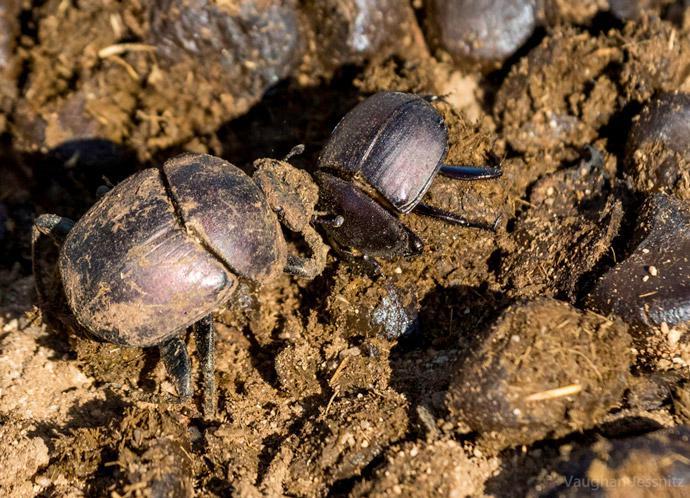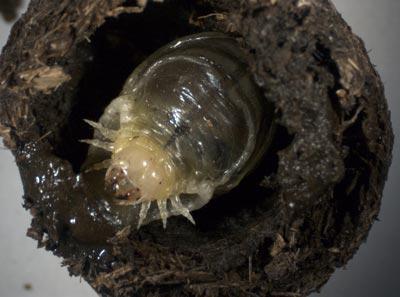The first image is the image on the left, the second image is the image on the right. Evaluate the accuracy of this statement regarding the images: "Each image contains a single rounded dung ball, and at least one image contains two beetles.". Is it true? Answer yes or no. No. The first image is the image on the left, the second image is the image on the right. For the images shown, is this caption "One image displays two beetles on the same dung ball." true? Answer yes or no. No. 